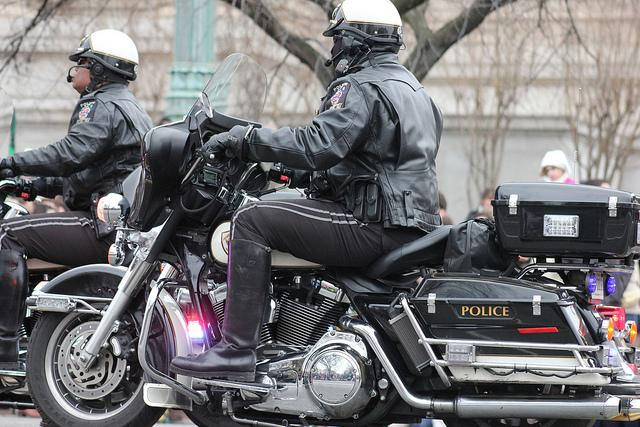What would be one main reason a police would be riding this type of motorcycle? Please explain your reasoning. looks. Cops are riding motorcycles in a street. 